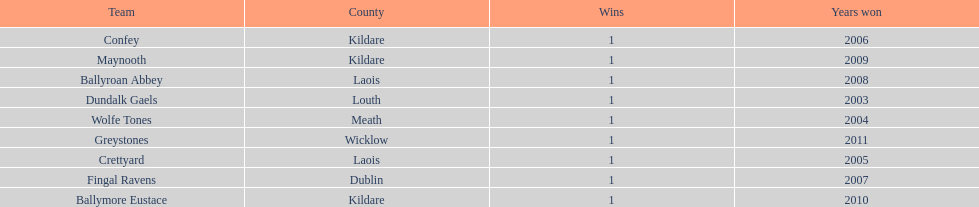What is the number of wins for confey 1. 